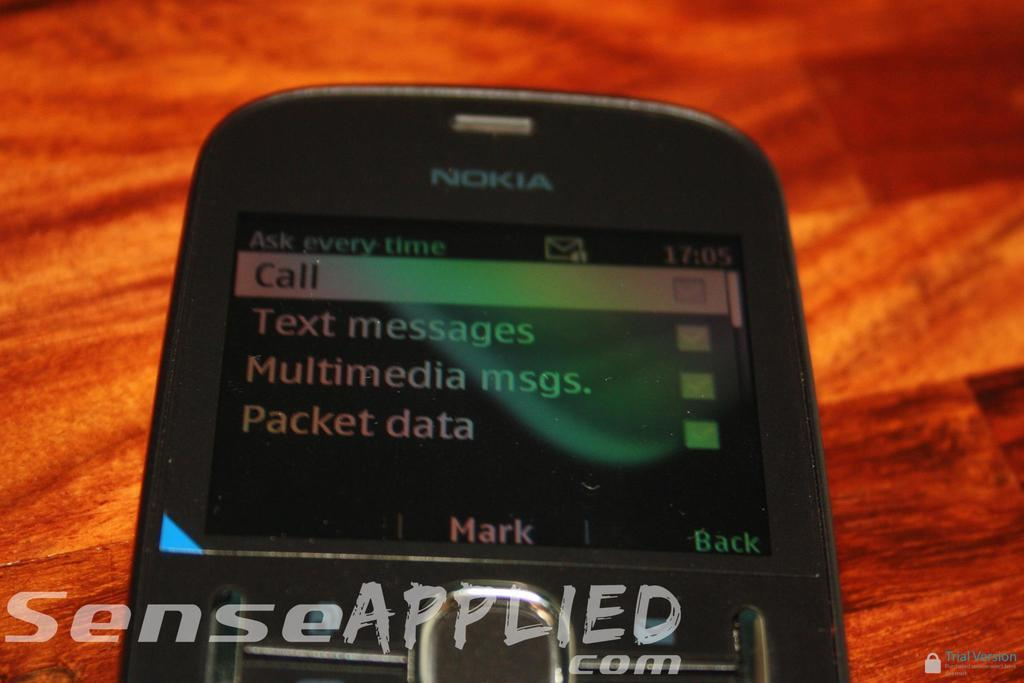<image>
Describe the image concisely. A black phone from Nokia is on a wooden table. 